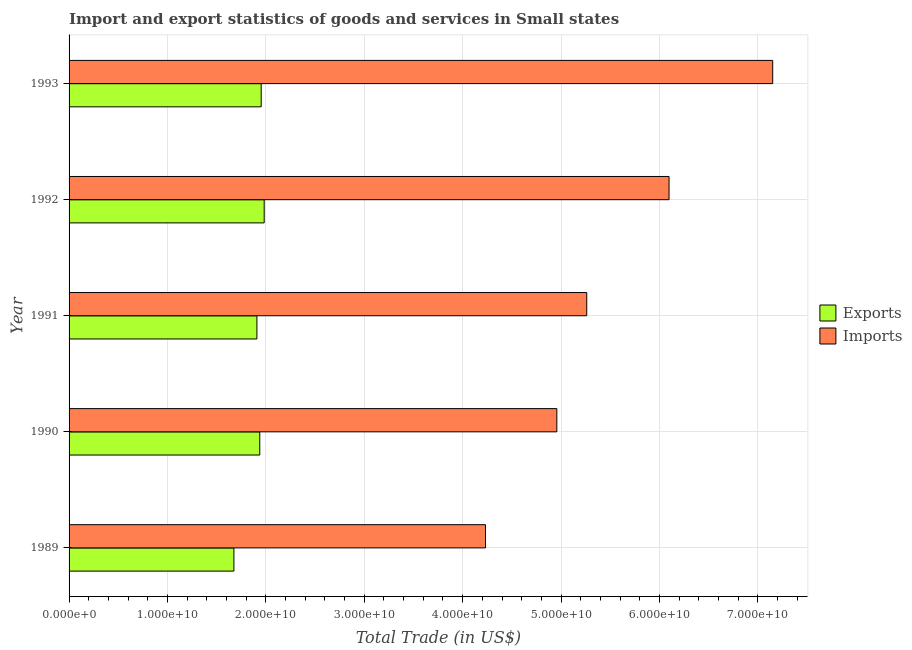How many bars are there on the 3rd tick from the top?
Your response must be concise. 2. How many bars are there on the 2nd tick from the bottom?
Give a very brief answer. 2. In how many cases, is the number of bars for a given year not equal to the number of legend labels?
Keep it short and to the point. 0. What is the export of goods and services in 1990?
Your answer should be compact. 1.94e+1. Across all years, what is the maximum export of goods and services?
Your response must be concise. 1.98e+1. Across all years, what is the minimum imports of goods and services?
Make the answer very short. 4.23e+1. In which year was the imports of goods and services maximum?
Your answer should be very brief. 1993. What is the total export of goods and services in the graph?
Offer a very short reply. 9.46e+1. What is the difference between the imports of goods and services in 1990 and that in 1991?
Your answer should be compact. -3.04e+09. What is the difference between the export of goods and services in 1989 and the imports of goods and services in 1993?
Your answer should be very brief. -5.48e+1. What is the average export of goods and services per year?
Your answer should be compact. 1.89e+1. In the year 1990, what is the difference between the export of goods and services and imports of goods and services?
Your answer should be very brief. -3.02e+1. What is the ratio of the export of goods and services in 1992 to that in 1993?
Your response must be concise. 1.02. Is the difference between the imports of goods and services in 1990 and 1991 greater than the difference between the export of goods and services in 1990 and 1991?
Your answer should be compact. No. What is the difference between the highest and the second highest export of goods and services?
Offer a terse response. 3.05e+08. What is the difference between the highest and the lowest export of goods and services?
Give a very brief answer. 3.08e+09. In how many years, is the imports of goods and services greater than the average imports of goods and services taken over all years?
Keep it short and to the point. 2. What does the 1st bar from the top in 1992 represents?
Your answer should be compact. Imports. What does the 1st bar from the bottom in 1992 represents?
Provide a succinct answer. Exports. How many bars are there?
Give a very brief answer. 10. How many years are there in the graph?
Ensure brevity in your answer.  5. Are the values on the major ticks of X-axis written in scientific E-notation?
Ensure brevity in your answer.  Yes. Does the graph contain grids?
Provide a succinct answer. Yes. How many legend labels are there?
Give a very brief answer. 2. How are the legend labels stacked?
Provide a succinct answer. Vertical. What is the title of the graph?
Give a very brief answer. Import and export statistics of goods and services in Small states. Does "Private creditors" appear as one of the legend labels in the graph?
Offer a very short reply. No. What is the label or title of the X-axis?
Your answer should be very brief. Total Trade (in US$). What is the label or title of the Y-axis?
Offer a terse response. Year. What is the Total Trade (in US$) of Exports in 1989?
Provide a short and direct response. 1.68e+1. What is the Total Trade (in US$) in Imports in 1989?
Your answer should be very brief. 4.23e+1. What is the Total Trade (in US$) in Exports in 1990?
Keep it short and to the point. 1.94e+1. What is the Total Trade (in US$) of Imports in 1990?
Provide a short and direct response. 4.96e+1. What is the Total Trade (in US$) in Exports in 1991?
Ensure brevity in your answer.  1.91e+1. What is the Total Trade (in US$) in Imports in 1991?
Your answer should be compact. 5.26e+1. What is the Total Trade (in US$) of Exports in 1992?
Give a very brief answer. 1.98e+1. What is the Total Trade (in US$) of Imports in 1992?
Offer a very short reply. 6.10e+1. What is the Total Trade (in US$) of Exports in 1993?
Offer a terse response. 1.95e+1. What is the Total Trade (in US$) in Imports in 1993?
Keep it short and to the point. 7.15e+1. Across all years, what is the maximum Total Trade (in US$) of Exports?
Keep it short and to the point. 1.98e+1. Across all years, what is the maximum Total Trade (in US$) of Imports?
Offer a terse response. 7.15e+1. Across all years, what is the minimum Total Trade (in US$) of Exports?
Ensure brevity in your answer.  1.68e+1. Across all years, what is the minimum Total Trade (in US$) of Imports?
Offer a very short reply. 4.23e+1. What is the total Total Trade (in US$) of Exports in the graph?
Offer a very short reply. 9.46e+1. What is the total Total Trade (in US$) of Imports in the graph?
Offer a terse response. 2.77e+11. What is the difference between the Total Trade (in US$) of Exports in 1989 and that in 1990?
Offer a terse response. -2.63e+09. What is the difference between the Total Trade (in US$) in Imports in 1989 and that in 1990?
Your response must be concise. -7.25e+09. What is the difference between the Total Trade (in US$) in Exports in 1989 and that in 1991?
Give a very brief answer. -2.34e+09. What is the difference between the Total Trade (in US$) of Imports in 1989 and that in 1991?
Make the answer very short. -1.03e+1. What is the difference between the Total Trade (in US$) in Exports in 1989 and that in 1992?
Your answer should be very brief. -3.08e+09. What is the difference between the Total Trade (in US$) in Imports in 1989 and that in 1992?
Keep it short and to the point. -1.87e+1. What is the difference between the Total Trade (in US$) in Exports in 1989 and that in 1993?
Your response must be concise. -2.77e+09. What is the difference between the Total Trade (in US$) in Imports in 1989 and that in 1993?
Offer a very short reply. -2.92e+1. What is the difference between the Total Trade (in US$) of Exports in 1990 and that in 1991?
Give a very brief answer. 2.92e+08. What is the difference between the Total Trade (in US$) of Imports in 1990 and that in 1991?
Provide a succinct answer. -3.04e+09. What is the difference between the Total Trade (in US$) of Exports in 1990 and that in 1992?
Keep it short and to the point. -4.50e+08. What is the difference between the Total Trade (in US$) of Imports in 1990 and that in 1992?
Offer a terse response. -1.14e+1. What is the difference between the Total Trade (in US$) in Exports in 1990 and that in 1993?
Make the answer very short. -1.45e+08. What is the difference between the Total Trade (in US$) of Imports in 1990 and that in 1993?
Offer a terse response. -2.19e+1. What is the difference between the Total Trade (in US$) in Exports in 1991 and that in 1992?
Provide a succinct answer. -7.41e+08. What is the difference between the Total Trade (in US$) of Imports in 1991 and that in 1992?
Offer a terse response. -8.36e+09. What is the difference between the Total Trade (in US$) of Exports in 1991 and that in 1993?
Provide a succinct answer. -4.37e+08. What is the difference between the Total Trade (in US$) in Imports in 1991 and that in 1993?
Ensure brevity in your answer.  -1.89e+1. What is the difference between the Total Trade (in US$) of Exports in 1992 and that in 1993?
Offer a very short reply. 3.05e+08. What is the difference between the Total Trade (in US$) of Imports in 1992 and that in 1993?
Provide a short and direct response. -1.05e+1. What is the difference between the Total Trade (in US$) of Exports in 1989 and the Total Trade (in US$) of Imports in 1990?
Your response must be concise. -3.28e+1. What is the difference between the Total Trade (in US$) of Exports in 1989 and the Total Trade (in US$) of Imports in 1991?
Make the answer very short. -3.59e+1. What is the difference between the Total Trade (in US$) in Exports in 1989 and the Total Trade (in US$) in Imports in 1992?
Your answer should be compact. -4.42e+1. What is the difference between the Total Trade (in US$) of Exports in 1989 and the Total Trade (in US$) of Imports in 1993?
Keep it short and to the point. -5.48e+1. What is the difference between the Total Trade (in US$) of Exports in 1990 and the Total Trade (in US$) of Imports in 1991?
Give a very brief answer. -3.32e+1. What is the difference between the Total Trade (in US$) in Exports in 1990 and the Total Trade (in US$) in Imports in 1992?
Keep it short and to the point. -4.16e+1. What is the difference between the Total Trade (in US$) of Exports in 1990 and the Total Trade (in US$) of Imports in 1993?
Provide a short and direct response. -5.21e+1. What is the difference between the Total Trade (in US$) of Exports in 1991 and the Total Trade (in US$) of Imports in 1992?
Make the answer very short. -4.19e+1. What is the difference between the Total Trade (in US$) in Exports in 1991 and the Total Trade (in US$) in Imports in 1993?
Ensure brevity in your answer.  -5.24e+1. What is the difference between the Total Trade (in US$) in Exports in 1992 and the Total Trade (in US$) in Imports in 1993?
Ensure brevity in your answer.  -5.17e+1. What is the average Total Trade (in US$) of Exports per year?
Offer a very short reply. 1.89e+1. What is the average Total Trade (in US$) of Imports per year?
Provide a succinct answer. 5.54e+1. In the year 1989, what is the difference between the Total Trade (in US$) of Exports and Total Trade (in US$) of Imports?
Provide a short and direct response. -2.56e+1. In the year 1990, what is the difference between the Total Trade (in US$) of Exports and Total Trade (in US$) of Imports?
Keep it short and to the point. -3.02e+1. In the year 1991, what is the difference between the Total Trade (in US$) in Exports and Total Trade (in US$) in Imports?
Your answer should be very brief. -3.35e+1. In the year 1992, what is the difference between the Total Trade (in US$) of Exports and Total Trade (in US$) of Imports?
Your answer should be very brief. -4.11e+1. In the year 1993, what is the difference between the Total Trade (in US$) in Exports and Total Trade (in US$) in Imports?
Keep it short and to the point. -5.20e+1. What is the ratio of the Total Trade (in US$) of Exports in 1989 to that in 1990?
Your answer should be very brief. 0.86. What is the ratio of the Total Trade (in US$) of Imports in 1989 to that in 1990?
Make the answer very short. 0.85. What is the ratio of the Total Trade (in US$) of Exports in 1989 to that in 1991?
Your response must be concise. 0.88. What is the ratio of the Total Trade (in US$) in Imports in 1989 to that in 1991?
Make the answer very short. 0.8. What is the ratio of the Total Trade (in US$) of Exports in 1989 to that in 1992?
Provide a short and direct response. 0.84. What is the ratio of the Total Trade (in US$) of Imports in 1989 to that in 1992?
Your answer should be very brief. 0.69. What is the ratio of the Total Trade (in US$) of Exports in 1989 to that in 1993?
Keep it short and to the point. 0.86. What is the ratio of the Total Trade (in US$) of Imports in 1989 to that in 1993?
Offer a terse response. 0.59. What is the ratio of the Total Trade (in US$) in Exports in 1990 to that in 1991?
Ensure brevity in your answer.  1.02. What is the ratio of the Total Trade (in US$) of Imports in 1990 to that in 1991?
Make the answer very short. 0.94. What is the ratio of the Total Trade (in US$) in Exports in 1990 to that in 1992?
Offer a very short reply. 0.98. What is the ratio of the Total Trade (in US$) in Imports in 1990 to that in 1992?
Your answer should be compact. 0.81. What is the ratio of the Total Trade (in US$) of Exports in 1990 to that in 1993?
Your response must be concise. 0.99. What is the ratio of the Total Trade (in US$) of Imports in 1990 to that in 1993?
Your answer should be compact. 0.69. What is the ratio of the Total Trade (in US$) in Exports in 1991 to that in 1992?
Keep it short and to the point. 0.96. What is the ratio of the Total Trade (in US$) of Imports in 1991 to that in 1992?
Make the answer very short. 0.86. What is the ratio of the Total Trade (in US$) of Exports in 1991 to that in 1993?
Offer a terse response. 0.98. What is the ratio of the Total Trade (in US$) in Imports in 1991 to that in 1993?
Your response must be concise. 0.74. What is the ratio of the Total Trade (in US$) in Exports in 1992 to that in 1993?
Your answer should be very brief. 1.02. What is the ratio of the Total Trade (in US$) in Imports in 1992 to that in 1993?
Your answer should be very brief. 0.85. What is the difference between the highest and the second highest Total Trade (in US$) in Exports?
Keep it short and to the point. 3.05e+08. What is the difference between the highest and the second highest Total Trade (in US$) in Imports?
Keep it short and to the point. 1.05e+1. What is the difference between the highest and the lowest Total Trade (in US$) of Exports?
Make the answer very short. 3.08e+09. What is the difference between the highest and the lowest Total Trade (in US$) of Imports?
Keep it short and to the point. 2.92e+1. 